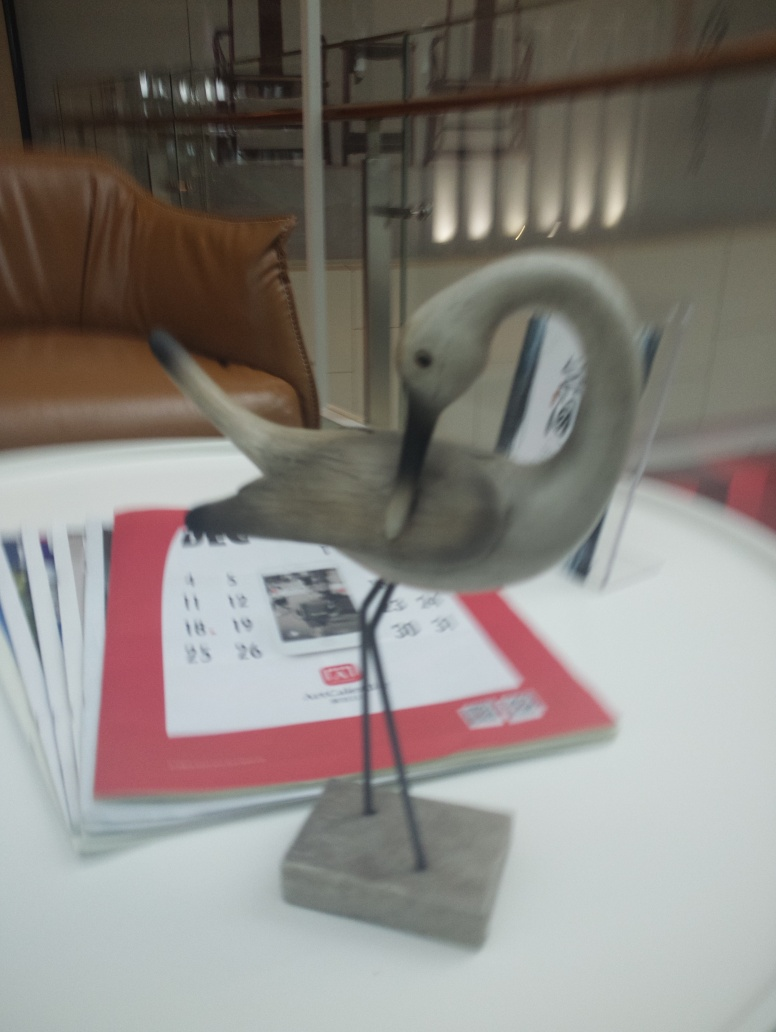Are the edges of the background unclear? Yes, the edges of the background appear somewhat unclear, which suggests that the photo may have been taken with a shallow depth of field or there was movement during the exposure, leading to a slight blur effect on the background elements. 